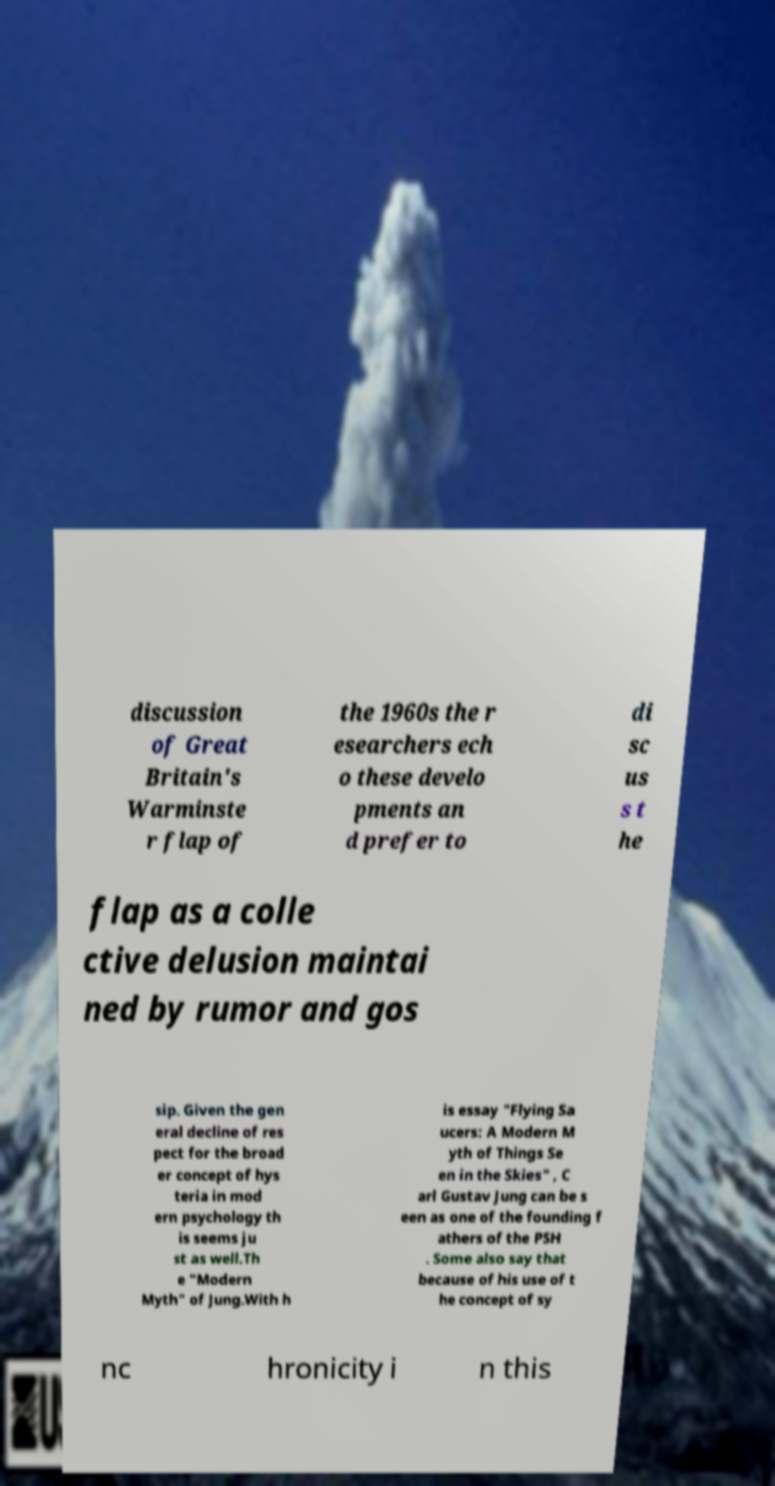Can you read and provide the text displayed in the image?This photo seems to have some interesting text. Can you extract and type it out for me? discussion of Great Britain's Warminste r flap of the 1960s the r esearchers ech o these develo pments an d prefer to di sc us s t he flap as a colle ctive delusion maintai ned by rumor and gos sip. Given the gen eral decline of res pect for the broad er concept of hys teria in mod ern psychology th is seems ju st as well.Th e "Modern Myth" of Jung.With h is essay "Flying Sa ucers: A Modern M yth of Things Se en in the Skies" , C arl Gustav Jung can be s een as one of the founding f athers of the PSH . Some also say that because of his use of t he concept of sy nc hronicity i n this 